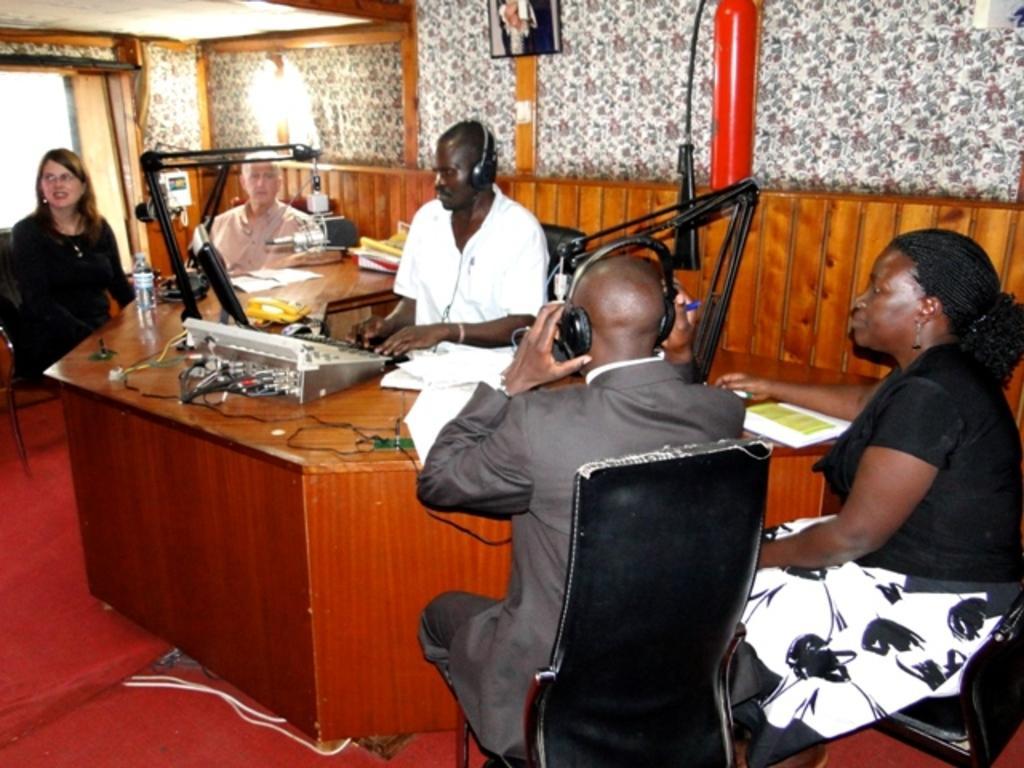In one or two sentences, can you explain what this image depicts? In this picture we can see few persons sitting on chairs in front of a table and on the table we can see an musical electronic device. These both men wore headset. This is a floor carpet. On the background we can see a decorative wall. This is a photo frame. 